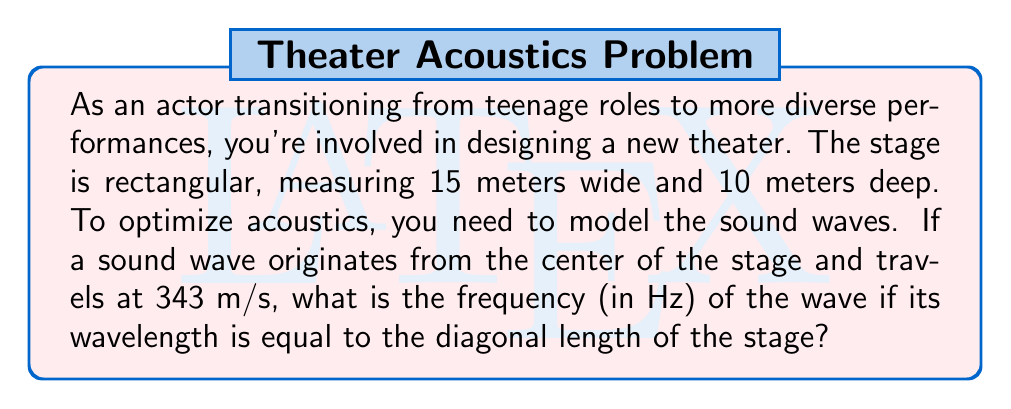Solve this math problem. Let's approach this step-by-step:

1) First, we need to find the diagonal length of the stage. We can use the Pythagorean theorem:

   $$d = \sqrt{w^2 + l^2}$$

   where $d$ is the diagonal, $w$ is the width, and $l$ is the length.

2) Plugging in the values:

   $$d = \sqrt{15^2 + 10^2} = \sqrt{225 + 100} = \sqrt{325} \approx 18.03 \text{ meters}$$

3) Now, we know that the wavelength $\lambda$ is equal to this diagonal length:

   $$\lambda \approx 18.03 \text{ meters}$$

4) We're given the speed of sound $v = 343 \text{ m/s}$. We can use the wave equation to find the frequency:

   $$v = f\lambda$$

   where $v$ is the wave speed, $f$ is the frequency, and $\lambda$ is the wavelength.

5) Rearranging to solve for $f$:

   $$f = \frac{v}{\lambda}$$

6) Substituting our values:

   $$f = \frac{343 \text{ m/s}}{18.03 \text{ m}} \approx 19.02 \text{ Hz}$$

Therefore, the frequency of the sound wave is approximately 19.02 Hz.
Answer: 19.02 Hz 